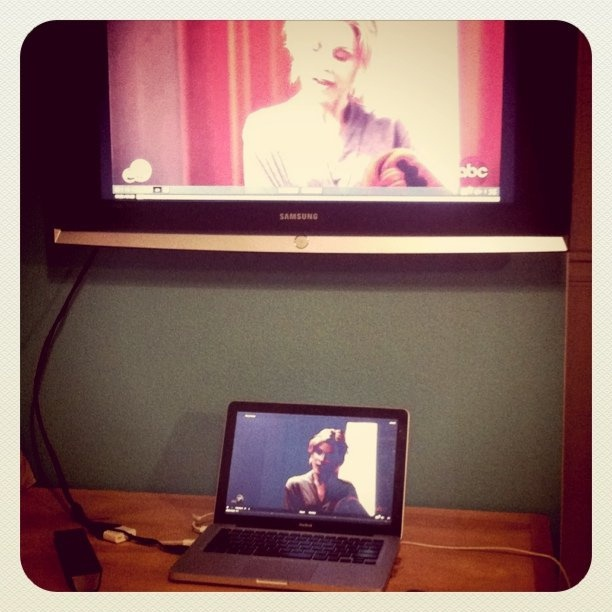Describe the objects in this image and their specific colors. I can see tv in ivory, black, beige, lightpink, and tan tones and laptop in ivory, black, maroon, gray, and purple tones in this image. 